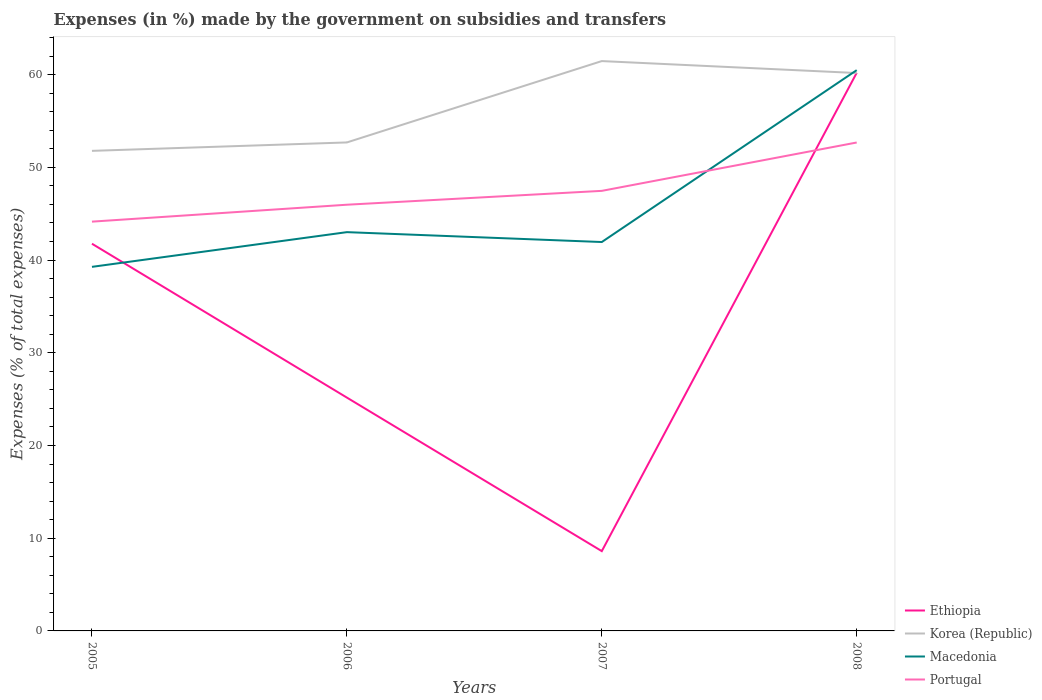How many different coloured lines are there?
Your answer should be very brief. 4. Is the number of lines equal to the number of legend labels?
Your response must be concise. Yes. Across all years, what is the maximum percentage of expenses made by the government on subsidies and transfers in Macedonia?
Offer a very short reply. 39.27. In which year was the percentage of expenses made by the government on subsidies and transfers in Macedonia maximum?
Provide a short and direct response. 2005. What is the total percentage of expenses made by the government on subsidies and transfers in Ethiopia in the graph?
Provide a succinct answer. -35.03. What is the difference between the highest and the second highest percentage of expenses made by the government on subsidies and transfers in Korea (Republic)?
Your answer should be compact. 9.68. Is the percentage of expenses made by the government on subsidies and transfers in Korea (Republic) strictly greater than the percentage of expenses made by the government on subsidies and transfers in Macedonia over the years?
Provide a short and direct response. No. How many years are there in the graph?
Provide a short and direct response. 4. What is the difference between two consecutive major ticks on the Y-axis?
Your response must be concise. 10. Are the values on the major ticks of Y-axis written in scientific E-notation?
Provide a short and direct response. No. Does the graph contain any zero values?
Provide a succinct answer. No. Where does the legend appear in the graph?
Give a very brief answer. Bottom right. How many legend labels are there?
Your answer should be compact. 4. What is the title of the graph?
Your answer should be compact. Expenses (in %) made by the government on subsidies and transfers. What is the label or title of the X-axis?
Your answer should be compact. Years. What is the label or title of the Y-axis?
Provide a short and direct response. Expenses (% of total expenses). What is the Expenses (% of total expenses) in Ethiopia in 2005?
Your answer should be very brief. 41.76. What is the Expenses (% of total expenses) of Korea (Republic) in 2005?
Your response must be concise. 51.77. What is the Expenses (% of total expenses) in Macedonia in 2005?
Your response must be concise. 39.27. What is the Expenses (% of total expenses) of Portugal in 2005?
Your answer should be very brief. 44.14. What is the Expenses (% of total expenses) in Ethiopia in 2006?
Give a very brief answer. 25.17. What is the Expenses (% of total expenses) in Korea (Republic) in 2006?
Provide a succinct answer. 52.68. What is the Expenses (% of total expenses) of Macedonia in 2006?
Provide a short and direct response. 43.01. What is the Expenses (% of total expenses) in Portugal in 2006?
Your answer should be compact. 45.97. What is the Expenses (% of total expenses) of Ethiopia in 2007?
Ensure brevity in your answer.  8.6. What is the Expenses (% of total expenses) of Korea (Republic) in 2007?
Make the answer very short. 61.46. What is the Expenses (% of total expenses) in Macedonia in 2007?
Provide a short and direct response. 41.94. What is the Expenses (% of total expenses) in Portugal in 2007?
Keep it short and to the point. 47.46. What is the Expenses (% of total expenses) of Ethiopia in 2008?
Keep it short and to the point. 60.19. What is the Expenses (% of total expenses) in Korea (Republic) in 2008?
Give a very brief answer. 60.17. What is the Expenses (% of total expenses) of Macedonia in 2008?
Offer a terse response. 60.48. What is the Expenses (% of total expenses) of Portugal in 2008?
Ensure brevity in your answer.  52.68. Across all years, what is the maximum Expenses (% of total expenses) in Ethiopia?
Ensure brevity in your answer.  60.19. Across all years, what is the maximum Expenses (% of total expenses) of Korea (Republic)?
Provide a succinct answer. 61.46. Across all years, what is the maximum Expenses (% of total expenses) of Macedonia?
Ensure brevity in your answer.  60.48. Across all years, what is the maximum Expenses (% of total expenses) of Portugal?
Your answer should be very brief. 52.68. Across all years, what is the minimum Expenses (% of total expenses) of Ethiopia?
Make the answer very short. 8.6. Across all years, what is the minimum Expenses (% of total expenses) in Korea (Republic)?
Your response must be concise. 51.77. Across all years, what is the minimum Expenses (% of total expenses) of Macedonia?
Ensure brevity in your answer.  39.27. Across all years, what is the minimum Expenses (% of total expenses) in Portugal?
Offer a very short reply. 44.14. What is the total Expenses (% of total expenses) of Ethiopia in the graph?
Offer a terse response. 135.72. What is the total Expenses (% of total expenses) in Korea (Republic) in the graph?
Ensure brevity in your answer.  226.08. What is the total Expenses (% of total expenses) of Macedonia in the graph?
Give a very brief answer. 184.69. What is the total Expenses (% of total expenses) of Portugal in the graph?
Ensure brevity in your answer.  190.25. What is the difference between the Expenses (% of total expenses) of Ethiopia in 2005 and that in 2006?
Provide a short and direct response. 16.59. What is the difference between the Expenses (% of total expenses) of Korea (Republic) in 2005 and that in 2006?
Your response must be concise. -0.91. What is the difference between the Expenses (% of total expenses) in Macedonia in 2005 and that in 2006?
Ensure brevity in your answer.  -3.74. What is the difference between the Expenses (% of total expenses) in Portugal in 2005 and that in 2006?
Provide a succinct answer. -1.83. What is the difference between the Expenses (% of total expenses) of Ethiopia in 2005 and that in 2007?
Your answer should be compact. 33.15. What is the difference between the Expenses (% of total expenses) in Korea (Republic) in 2005 and that in 2007?
Keep it short and to the point. -9.68. What is the difference between the Expenses (% of total expenses) of Macedonia in 2005 and that in 2007?
Your answer should be very brief. -2.68. What is the difference between the Expenses (% of total expenses) of Portugal in 2005 and that in 2007?
Keep it short and to the point. -3.32. What is the difference between the Expenses (% of total expenses) in Ethiopia in 2005 and that in 2008?
Give a very brief answer. -18.43. What is the difference between the Expenses (% of total expenses) in Korea (Republic) in 2005 and that in 2008?
Your answer should be very brief. -8.4. What is the difference between the Expenses (% of total expenses) of Macedonia in 2005 and that in 2008?
Keep it short and to the point. -21.21. What is the difference between the Expenses (% of total expenses) in Portugal in 2005 and that in 2008?
Provide a succinct answer. -8.54. What is the difference between the Expenses (% of total expenses) of Ethiopia in 2006 and that in 2007?
Offer a terse response. 16.56. What is the difference between the Expenses (% of total expenses) of Korea (Republic) in 2006 and that in 2007?
Keep it short and to the point. -8.77. What is the difference between the Expenses (% of total expenses) in Macedonia in 2006 and that in 2007?
Provide a short and direct response. 1.07. What is the difference between the Expenses (% of total expenses) of Portugal in 2006 and that in 2007?
Your answer should be very brief. -1.49. What is the difference between the Expenses (% of total expenses) in Ethiopia in 2006 and that in 2008?
Ensure brevity in your answer.  -35.03. What is the difference between the Expenses (% of total expenses) of Korea (Republic) in 2006 and that in 2008?
Offer a very short reply. -7.49. What is the difference between the Expenses (% of total expenses) of Macedonia in 2006 and that in 2008?
Provide a short and direct response. -17.47. What is the difference between the Expenses (% of total expenses) of Portugal in 2006 and that in 2008?
Your answer should be compact. -6.71. What is the difference between the Expenses (% of total expenses) of Ethiopia in 2007 and that in 2008?
Keep it short and to the point. -51.59. What is the difference between the Expenses (% of total expenses) in Korea (Republic) in 2007 and that in 2008?
Provide a succinct answer. 1.29. What is the difference between the Expenses (% of total expenses) of Macedonia in 2007 and that in 2008?
Give a very brief answer. -18.54. What is the difference between the Expenses (% of total expenses) in Portugal in 2007 and that in 2008?
Your answer should be very brief. -5.22. What is the difference between the Expenses (% of total expenses) of Ethiopia in 2005 and the Expenses (% of total expenses) of Korea (Republic) in 2006?
Your answer should be very brief. -10.92. What is the difference between the Expenses (% of total expenses) of Ethiopia in 2005 and the Expenses (% of total expenses) of Macedonia in 2006?
Your answer should be very brief. -1.25. What is the difference between the Expenses (% of total expenses) of Ethiopia in 2005 and the Expenses (% of total expenses) of Portugal in 2006?
Ensure brevity in your answer.  -4.21. What is the difference between the Expenses (% of total expenses) of Korea (Republic) in 2005 and the Expenses (% of total expenses) of Macedonia in 2006?
Give a very brief answer. 8.77. What is the difference between the Expenses (% of total expenses) in Korea (Republic) in 2005 and the Expenses (% of total expenses) in Portugal in 2006?
Ensure brevity in your answer.  5.81. What is the difference between the Expenses (% of total expenses) of Macedonia in 2005 and the Expenses (% of total expenses) of Portugal in 2006?
Keep it short and to the point. -6.7. What is the difference between the Expenses (% of total expenses) in Ethiopia in 2005 and the Expenses (% of total expenses) in Korea (Republic) in 2007?
Give a very brief answer. -19.7. What is the difference between the Expenses (% of total expenses) in Ethiopia in 2005 and the Expenses (% of total expenses) in Macedonia in 2007?
Keep it short and to the point. -0.18. What is the difference between the Expenses (% of total expenses) in Ethiopia in 2005 and the Expenses (% of total expenses) in Portugal in 2007?
Ensure brevity in your answer.  -5.7. What is the difference between the Expenses (% of total expenses) in Korea (Republic) in 2005 and the Expenses (% of total expenses) in Macedonia in 2007?
Ensure brevity in your answer.  9.83. What is the difference between the Expenses (% of total expenses) in Korea (Republic) in 2005 and the Expenses (% of total expenses) in Portugal in 2007?
Your answer should be compact. 4.31. What is the difference between the Expenses (% of total expenses) of Macedonia in 2005 and the Expenses (% of total expenses) of Portugal in 2007?
Make the answer very short. -8.2. What is the difference between the Expenses (% of total expenses) of Ethiopia in 2005 and the Expenses (% of total expenses) of Korea (Republic) in 2008?
Your response must be concise. -18.41. What is the difference between the Expenses (% of total expenses) in Ethiopia in 2005 and the Expenses (% of total expenses) in Macedonia in 2008?
Provide a short and direct response. -18.72. What is the difference between the Expenses (% of total expenses) in Ethiopia in 2005 and the Expenses (% of total expenses) in Portugal in 2008?
Provide a short and direct response. -10.92. What is the difference between the Expenses (% of total expenses) in Korea (Republic) in 2005 and the Expenses (% of total expenses) in Macedonia in 2008?
Offer a very short reply. -8.7. What is the difference between the Expenses (% of total expenses) in Korea (Republic) in 2005 and the Expenses (% of total expenses) in Portugal in 2008?
Give a very brief answer. -0.9. What is the difference between the Expenses (% of total expenses) in Macedonia in 2005 and the Expenses (% of total expenses) in Portugal in 2008?
Your answer should be compact. -13.41. What is the difference between the Expenses (% of total expenses) in Ethiopia in 2006 and the Expenses (% of total expenses) in Korea (Republic) in 2007?
Provide a short and direct response. -36.29. What is the difference between the Expenses (% of total expenses) of Ethiopia in 2006 and the Expenses (% of total expenses) of Macedonia in 2007?
Ensure brevity in your answer.  -16.78. What is the difference between the Expenses (% of total expenses) in Ethiopia in 2006 and the Expenses (% of total expenses) in Portugal in 2007?
Your answer should be very brief. -22.3. What is the difference between the Expenses (% of total expenses) of Korea (Republic) in 2006 and the Expenses (% of total expenses) of Macedonia in 2007?
Your answer should be compact. 10.74. What is the difference between the Expenses (% of total expenses) in Korea (Republic) in 2006 and the Expenses (% of total expenses) in Portugal in 2007?
Ensure brevity in your answer.  5.22. What is the difference between the Expenses (% of total expenses) of Macedonia in 2006 and the Expenses (% of total expenses) of Portugal in 2007?
Make the answer very short. -4.45. What is the difference between the Expenses (% of total expenses) of Ethiopia in 2006 and the Expenses (% of total expenses) of Korea (Republic) in 2008?
Ensure brevity in your answer.  -35. What is the difference between the Expenses (% of total expenses) of Ethiopia in 2006 and the Expenses (% of total expenses) of Macedonia in 2008?
Offer a very short reply. -35.31. What is the difference between the Expenses (% of total expenses) in Ethiopia in 2006 and the Expenses (% of total expenses) in Portugal in 2008?
Keep it short and to the point. -27.51. What is the difference between the Expenses (% of total expenses) in Korea (Republic) in 2006 and the Expenses (% of total expenses) in Macedonia in 2008?
Your response must be concise. -7.8. What is the difference between the Expenses (% of total expenses) of Korea (Republic) in 2006 and the Expenses (% of total expenses) of Portugal in 2008?
Your response must be concise. 0.01. What is the difference between the Expenses (% of total expenses) of Macedonia in 2006 and the Expenses (% of total expenses) of Portugal in 2008?
Provide a short and direct response. -9.67. What is the difference between the Expenses (% of total expenses) in Ethiopia in 2007 and the Expenses (% of total expenses) in Korea (Republic) in 2008?
Offer a terse response. -51.56. What is the difference between the Expenses (% of total expenses) of Ethiopia in 2007 and the Expenses (% of total expenses) of Macedonia in 2008?
Offer a very short reply. -51.87. What is the difference between the Expenses (% of total expenses) in Ethiopia in 2007 and the Expenses (% of total expenses) in Portugal in 2008?
Offer a very short reply. -44.07. What is the difference between the Expenses (% of total expenses) of Korea (Republic) in 2007 and the Expenses (% of total expenses) of Macedonia in 2008?
Ensure brevity in your answer.  0.98. What is the difference between the Expenses (% of total expenses) of Korea (Republic) in 2007 and the Expenses (% of total expenses) of Portugal in 2008?
Your response must be concise. 8.78. What is the difference between the Expenses (% of total expenses) of Macedonia in 2007 and the Expenses (% of total expenses) of Portugal in 2008?
Give a very brief answer. -10.73. What is the average Expenses (% of total expenses) of Ethiopia per year?
Provide a short and direct response. 33.93. What is the average Expenses (% of total expenses) of Korea (Republic) per year?
Your answer should be compact. 56.52. What is the average Expenses (% of total expenses) in Macedonia per year?
Your answer should be very brief. 46.17. What is the average Expenses (% of total expenses) in Portugal per year?
Provide a succinct answer. 47.56. In the year 2005, what is the difference between the Expenses (% of total expenses) in Ethiopia and Expenses (% of total expenses) in Korea (Republic)?
Ensure brevity in your answer.  -10.01. In the year 2005, what is the difference between the Expenses (% of total expenses) in Ethiopia and Expenses (% of total expenses) in Macedonia?
Make the answer very short. 2.49. In the year 2005, what is the difference between the Expenses (% of total expenses) of Ethiopia and Expenses (% of total expenses) of Portugal?
Ensure brevity in your answer.  -2.38. In the year 2005, what is the difference between the Expenses (% of total expenses) of Korea (Republic) and Expenses (% of total expenses) of Macedonia?
Provide a succinct answer. 12.51. In the year 2005, what is the difference between the Expenses (% of total expenses) in Korea (Republic) and Expenses (% of total expenses) in Portugal?
Provide a short and direct response. 7.63. In the year 2005, what is the difference between the Expenses (% of total expenses) of Macedonia and Expenses (% of total expenses) of Portugal?
Your answer should be compact. -4.88. In the year 2006, what is the difference between the Expenses (% of total expenses) in Ethiopia and Expenses (% of total expenses) in Korea (Republic)?
Your response must be concise. -27.52. In the year 2006, what is the difference between the Expenses (% of total expenses) in Ethiopia and Expenses (% of total expenses) in Macedonia?
Offer a terse response. -17.84. In the year 2006, what is the difference between the Expenses (% of total expenses) in Ethiopia and Expenses (% of total expenses) in Portugal?
Offer a terse response. -20.8. In the year 2006, what is the difference between the Expenses (% of total expenses) in Korea (Republic) and Expenses (% of total expenses) in Macedonia?
Offer a very short reply. 9.67. In the year 2006, what is the difference between the Expenses (% of total expenses) of Korea (Republic) and Expenses (% of total expenses) of Portugal?
Your answer should be very brief. 6.72. In the year 2006, what is the difference between the Expenses (% of total expenses) in Macedonia and Expenses (% of total expenses) in Portugal?
Make the answer very short. -2.96. In the year 2007, what is the difference between the Expenses (% of total expenses) of Ethiopia and Expenses (% of total expenses) of Korea (Republic)?
Your answer should be very brief. -52.85. In the year 2007, what is the difference between the Expenses (% of total expenses) of Ethiopia and Expenses (% of total expenses) of Macedonia?
Make the answer very short. -33.34. In the year 2007, what is the difference between the Expenses (% of total expenses) in Ethiopia and Expenses (% of total expenses) in Portugal?
Your response must be concise. -38.86. In the year 2007, what is the difference between the Expenses (% of total expenses) of Korea (Republic) and Expenses (% of total expenses) of Macedonia?
Provide a short and direct response. 19.52. In the year 2007, what is the difference between the Expenses (% of total expenses) in Korea (Republic) and Expenses (% of total expenses) in Portugal?
Ensure brevity in your answer.  14. In the year 2007, what is the difference between the Expenses (% of total expenses) in Macedonia and Expenses (% of total expenses) in Portugal?
Provide a short and direct response. -5.52. In the year 2008, what is the difference between the Expenses (% of total expenses) in Ethiopia and Expenses (% of total expenses) in Korea (Republic)?
Ensure brevity in your answer.  0.02. In the year 2008, what is the difference between the Expenses (% of total expenses) of Ethiopia and Expenses (% of total expenses) of Macedonia?
Keep it short and to the point. -0.29. In the year 2008, what is the difference between the Expenses (% of total expenses) in Ethiopia and Expenses (% of total expenses) in Portugal?
Keep it short and to the point. 7.52. In the year 2008, what is the difference between the Expenses (% of total expenses) of Korea (Republic) and Expenses (% of total expenses) of Macedonia?
Make the answer very short. -0.31. In the year 2008, what is the difference between the Expenses (% of total expenses) in Korea (Republic) and Expenses (% of total expenses) in Portugal?
Offer a terse response. 7.49. In the year 2008, what is the difference between the Expenses (% of total expenses) in Macedonia and Expenses (% of total expenses) in Portugal?
Offer a very short reply. 7.8. What is the ratio of the Expenses (% of total expenses) of Ethiopia in 2005 to that in 2006?
Your response must be concise. 1.66. What is the ratio of the Expenses (% of total expenses) of Korea (Republic) in 2005 to that in 2006?
Your response must be concise. 0.98. What is the ratio of the Expenses (% of total expenses) in Macedonia in 2005 to that in 2006?
Provide a short and direct response. 0.91. What is the ratio of the Expenses (% of total expenses) in Portugal in 2005 to that in 2006?
Give a very brief answer. 0.96. What is the ratio of the Expenses (% of total expenses) in Ethiopia in 2005 to that in 2007?
Provide a short and direct response. 4.85. What is the ratio of the Expenses (% of total expenses) of Korea (Republic) in 2005 to that in 2007?
Offer a very short reply. 0.84. What is the ratio of the Expenses (% of total expenses) of Macedonia in 2005 to that in 2007?
Provide a succinct answer. 0.94. What is the ratio of the Expenses (% of total expenses) of Portugal in 2005 to that in 2007?
Offer a terse response. 0.93. What is the ratio of the Expenses (% of total expenses) in Ethiopia in 2005 to that in 2008?
Your answer should be very brief. 0.69. What is the ratio of the Expenses (% of total expenses) of Korea (Republic) in 2005 to that in 2008?
Your answer should be very brief. 0.86. What is the ratio of the Expenses (% of total expenses) in Macedonia in 2005 to that in 2008?
Offer a very short reply. 0.65. What is the ratio of the Expenses (% of total expenses) of Portugal in 2005 to that in 2008?
Offer a terse response. 0.84. What is the ratio of the Expenses (% of total expenses) of Ethiopia in 2006 to that in 2007?
Offer a terse response. 2.92. What is the ratio of the Expenses (% of total expenses) of Korea (Republic) in 2006 to that in 2007?
Provide a short and direct response. 0.86. What is the ratio of the Expenses (% of total expenses) in Macedonia in 2006 to that in 2007?
Make the answer very short. 1.03. What is the ratio of the Expenses (% of total expenses) in Portugal in 2006 to that in 2007?
Make the answer very short. 0.97. What is the ratio of the Expenses (% of total expenses) in Ethiopia in 2006 to that in 2008?
Give a very brief answer. 0.42. What is the ratio of the Expenses (% of total expenses) in Korea (Republic) in 2006 to that in 2008?
Your response must be concise. 0.88. What is the ratio of the Expenses (% of total expenses) in Macedonia in 2006 to that in 2008?
Ensure brevity in your answer.  0.71. What is the ratio of the Expenses (% of total expenses) in Portugal in 2006 to that in 2008?
Give a very brief answer. 0.87. What is the ratio of the Expenses (% of total expenses) in Ethiopia in 2007 to that in 2008?
Keep it short and to the point. 0.14. What is the ratio of the Expenses (% of total expenses) in Korea (Republic) in 2007 to that in 2008?
Your answer should be compact. 1.02. What is the ratio of the Expenses (% of total expenses) of Macedonia in 2007 to that in 2008?
Your answer should be compact. 0.69. What is the ratio of the Expenses (% of total expenses) of Portugal in 2007 to that in 2008?
Offer a very short reply. 0.9. What is the difference between the highest and the second highest Expenses (% of total expenses) in Ethiopia?
Your answer should be compact. 18.43. What is the difference between the highest and the second highest Expenses (% of total expenses) in Korea (Republic)?
Your answer should be compact. 1.29. What is the difference between the highest and the second highest Expenses (% of total expenses) in Macedonia?
Your response must be concise. 17.47. What is the difference between the highest and the second highest Expenses (% of total expenses) of Portugal?
Ensure brevity in your answer.  5.22. What is the difference between the highest and the lowest Expenses (% of total expenses) in Ethiopia?
Make the answer very short. 51.59. What is the difference between the highest and the lowest Expenses (% of total expenses) of Korea (Republic)?
Make the answer very short. 9.68. What is the difference between the highest and the lowest Expenses (% of total expenses) in Macedonia?
Provide a succinct answer. 21.21. What is the difference between the highest and the lowest Expenses (% of total expenses) of Portugal?
Offer a very short reply. 8.54. 